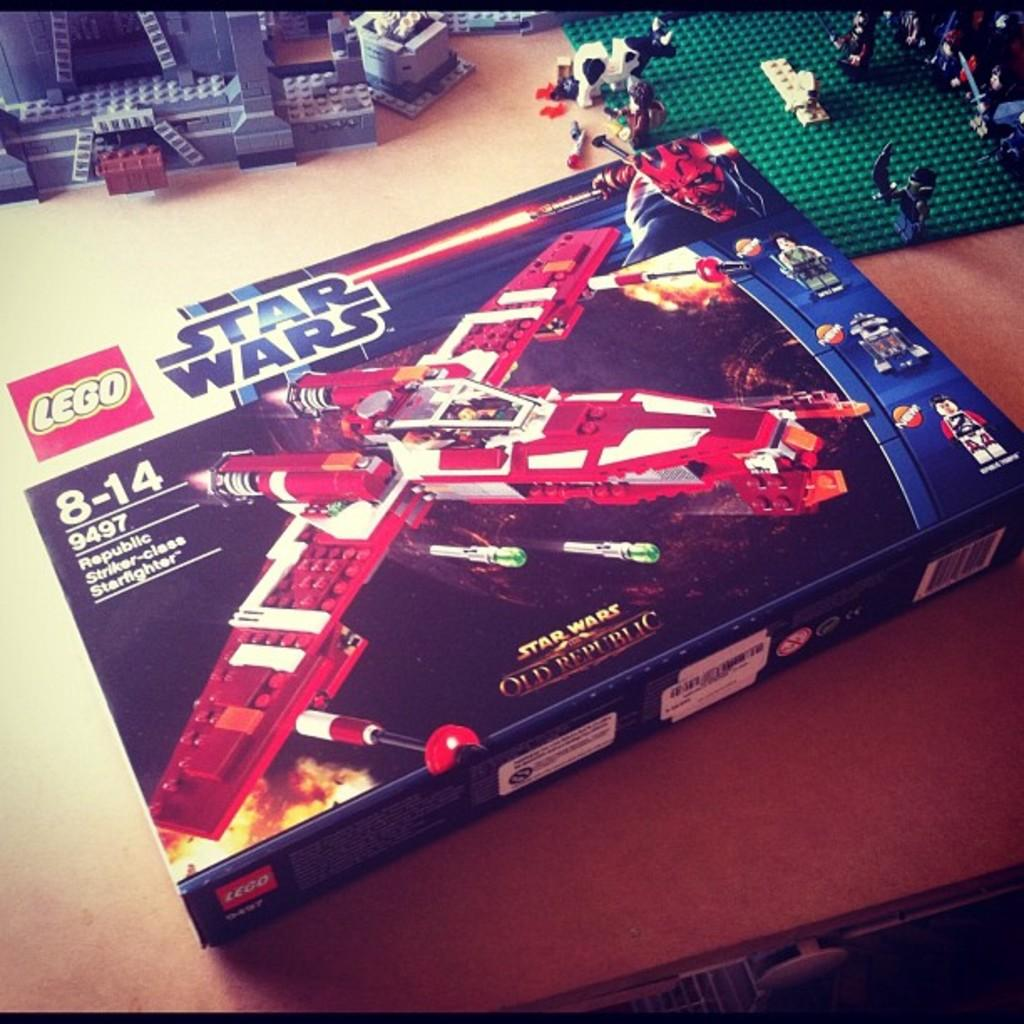What is the main object in the image? There is a toy box in the image. What is inside the toy box? There are toys in the image. What else can be seen on the table in the image? There are other objects on the table in the image. What is special about the toy box? The toy box has pictures of toys on it. Can you see anyone sneezing in the image? There is no one present in the image, so it is not possible to see anyone sneezing. 